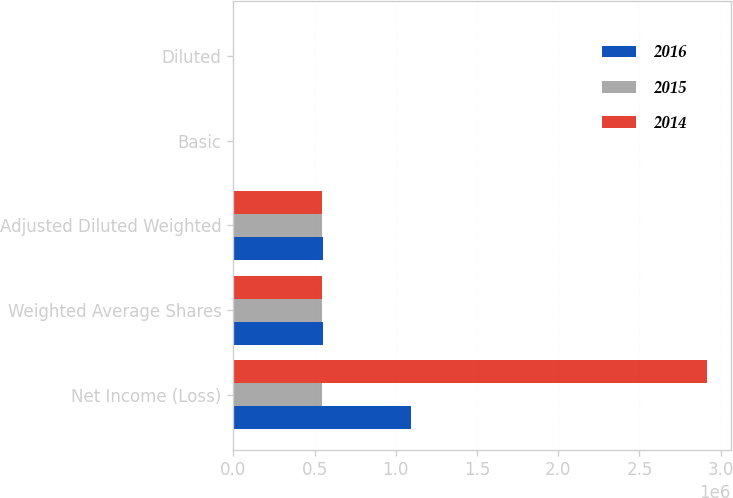Convert chart to OTSL. <chart><loc_0><loc_0><loc_500><loc_500><stacked_bar_chart><ecel><fcel>Net Income (Loss)<fcel>Weighted Average Shares<fcel>Adjusted Diluted Weighted<fcel>Basic<fcel>Diluted<nl><fcel>2016<fcel>1.09669e+06<fcel>553384<fcel>553384<fcel>1.98<fcel>1.98<nl><fcel>2015<fcel>544570<fcel>545697<fcel>545697<fcel>8.29<fcel>8.29<nl><fcel>2014<fcel>2.91549e+06<fcel>543443<fcel>548539<fcel>5.36<fcel>5.32<nl></chart> 